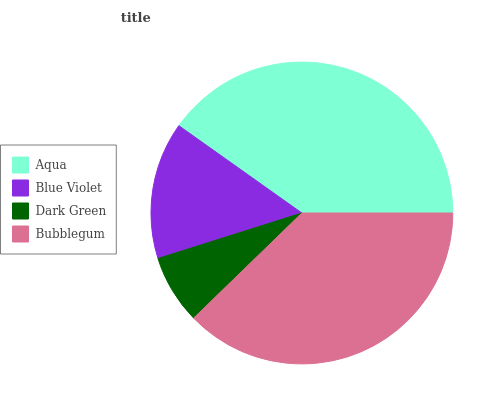Is Dark Green the minimum?
Answer yes or no. Yes. Is Aqua the maximum?
Answer yes or no. Yes. Is Blue Violet the minimum?
Answer yes or no. No. Is Blue Violet the maximum?
Answer yes or no. No. Is Aqua greater than Blue Violet?
Answer yes or no. Yes. Is Blue Violet less than Aqua?
Answer yes or no. Yes. Is Blue Violet greater than Aqua?
Answer yes or no. No. Is Aqua less than Blue Violet?
Answer yes or no. No. Is Bubblegum the high median?
Answer yes or no. Yes. Is Blue Violet the low median?
Answer yes or no. Yes. Is Dark Green the high median?
Answer yes or no. No. Is Bubblegum the low median?
Answer yes or no. No. 